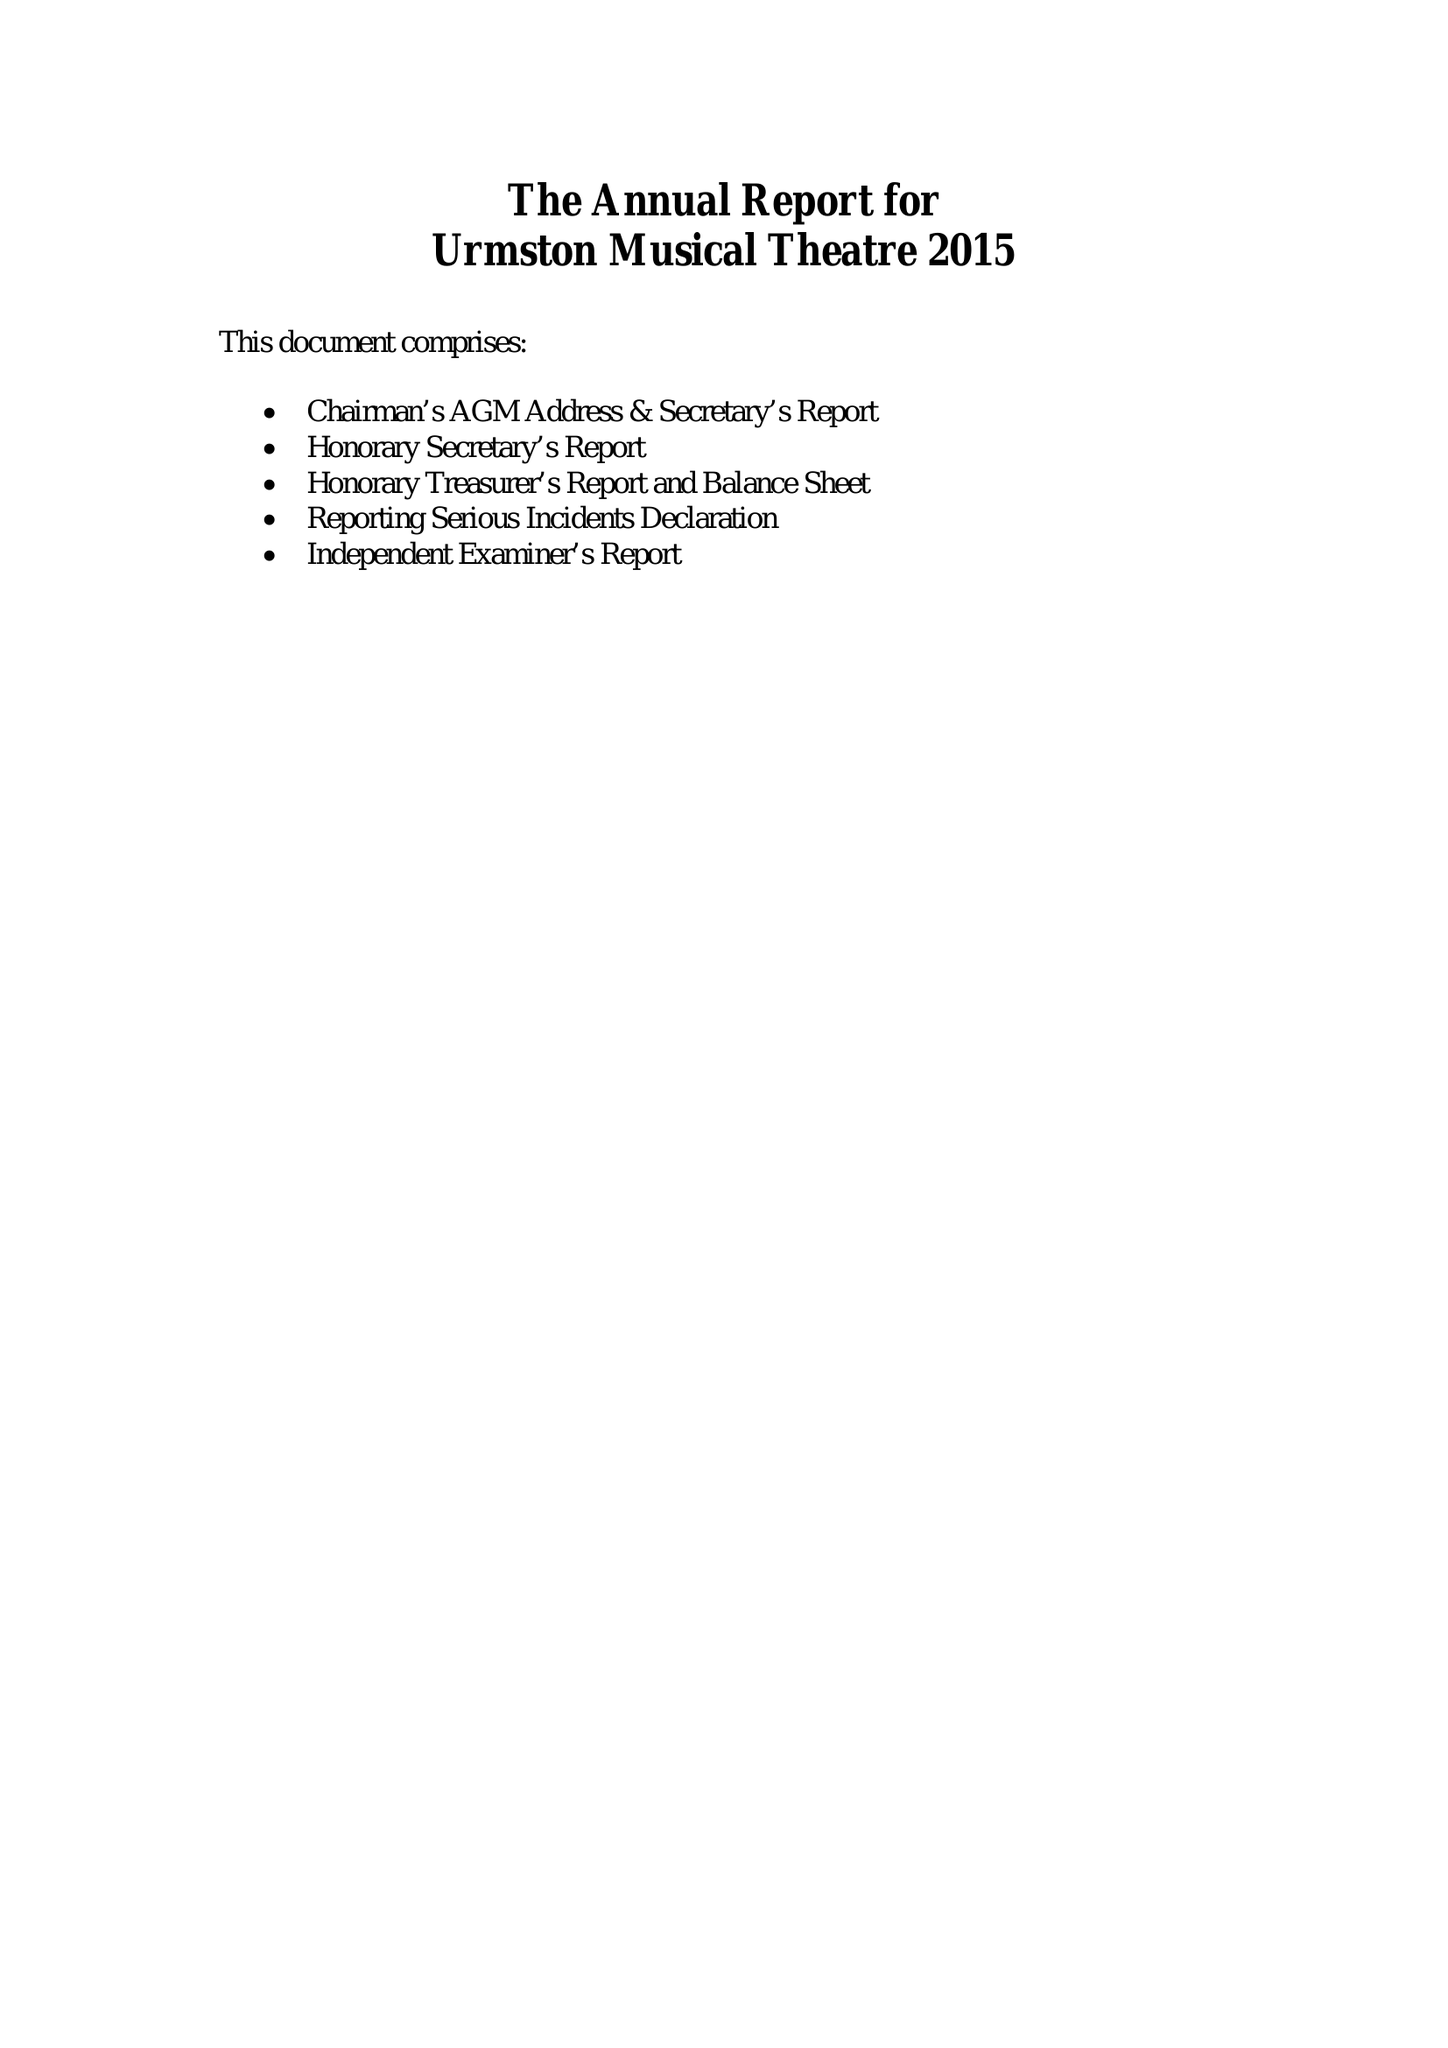What is the value for the charity_name?
Answer the question using a single word or phrase. Urmston Musical Theatre 